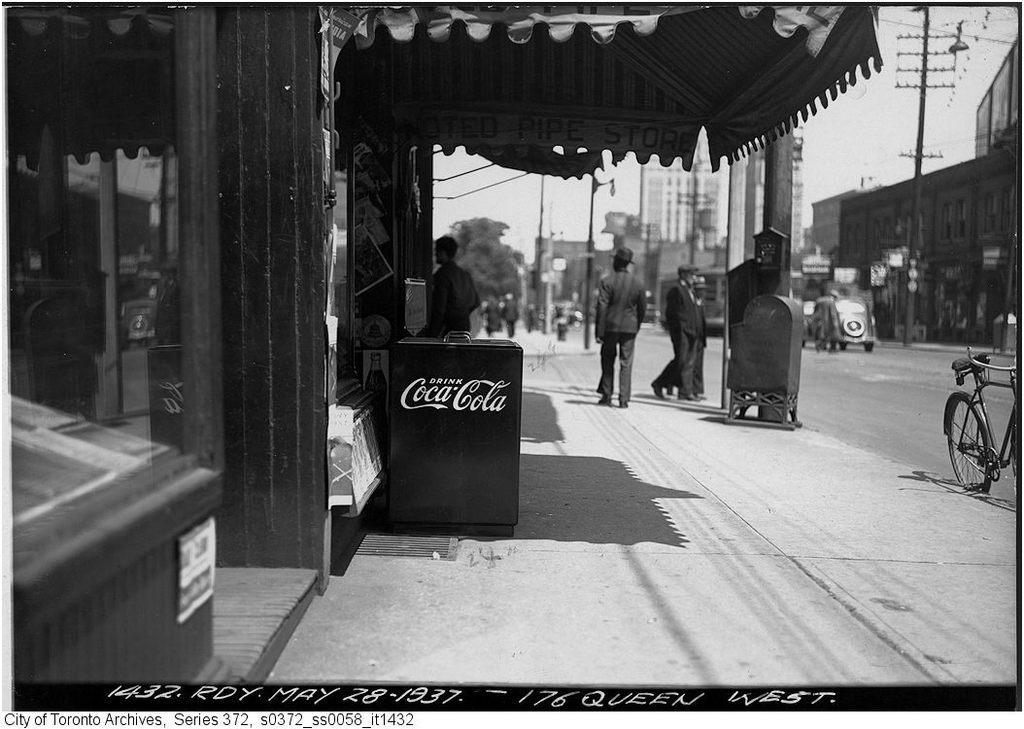Could you give a brief overview of what you see in this image? In this picture we can observe some people walking. There is a box placed here. We can observe a shop on the left side. There is a vehicle moving on this road. On the right side there is a bicycle. In the background there are buildings and poles. We can observe a sky. 